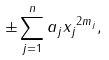<formula> <loc_0><loc_0><loc_500><loc_500>\pm \sum _ { j = 1 } ^ { n } a _ { j } { x _ { j } } ^ { 2 m _ { j } } ,</formula> 